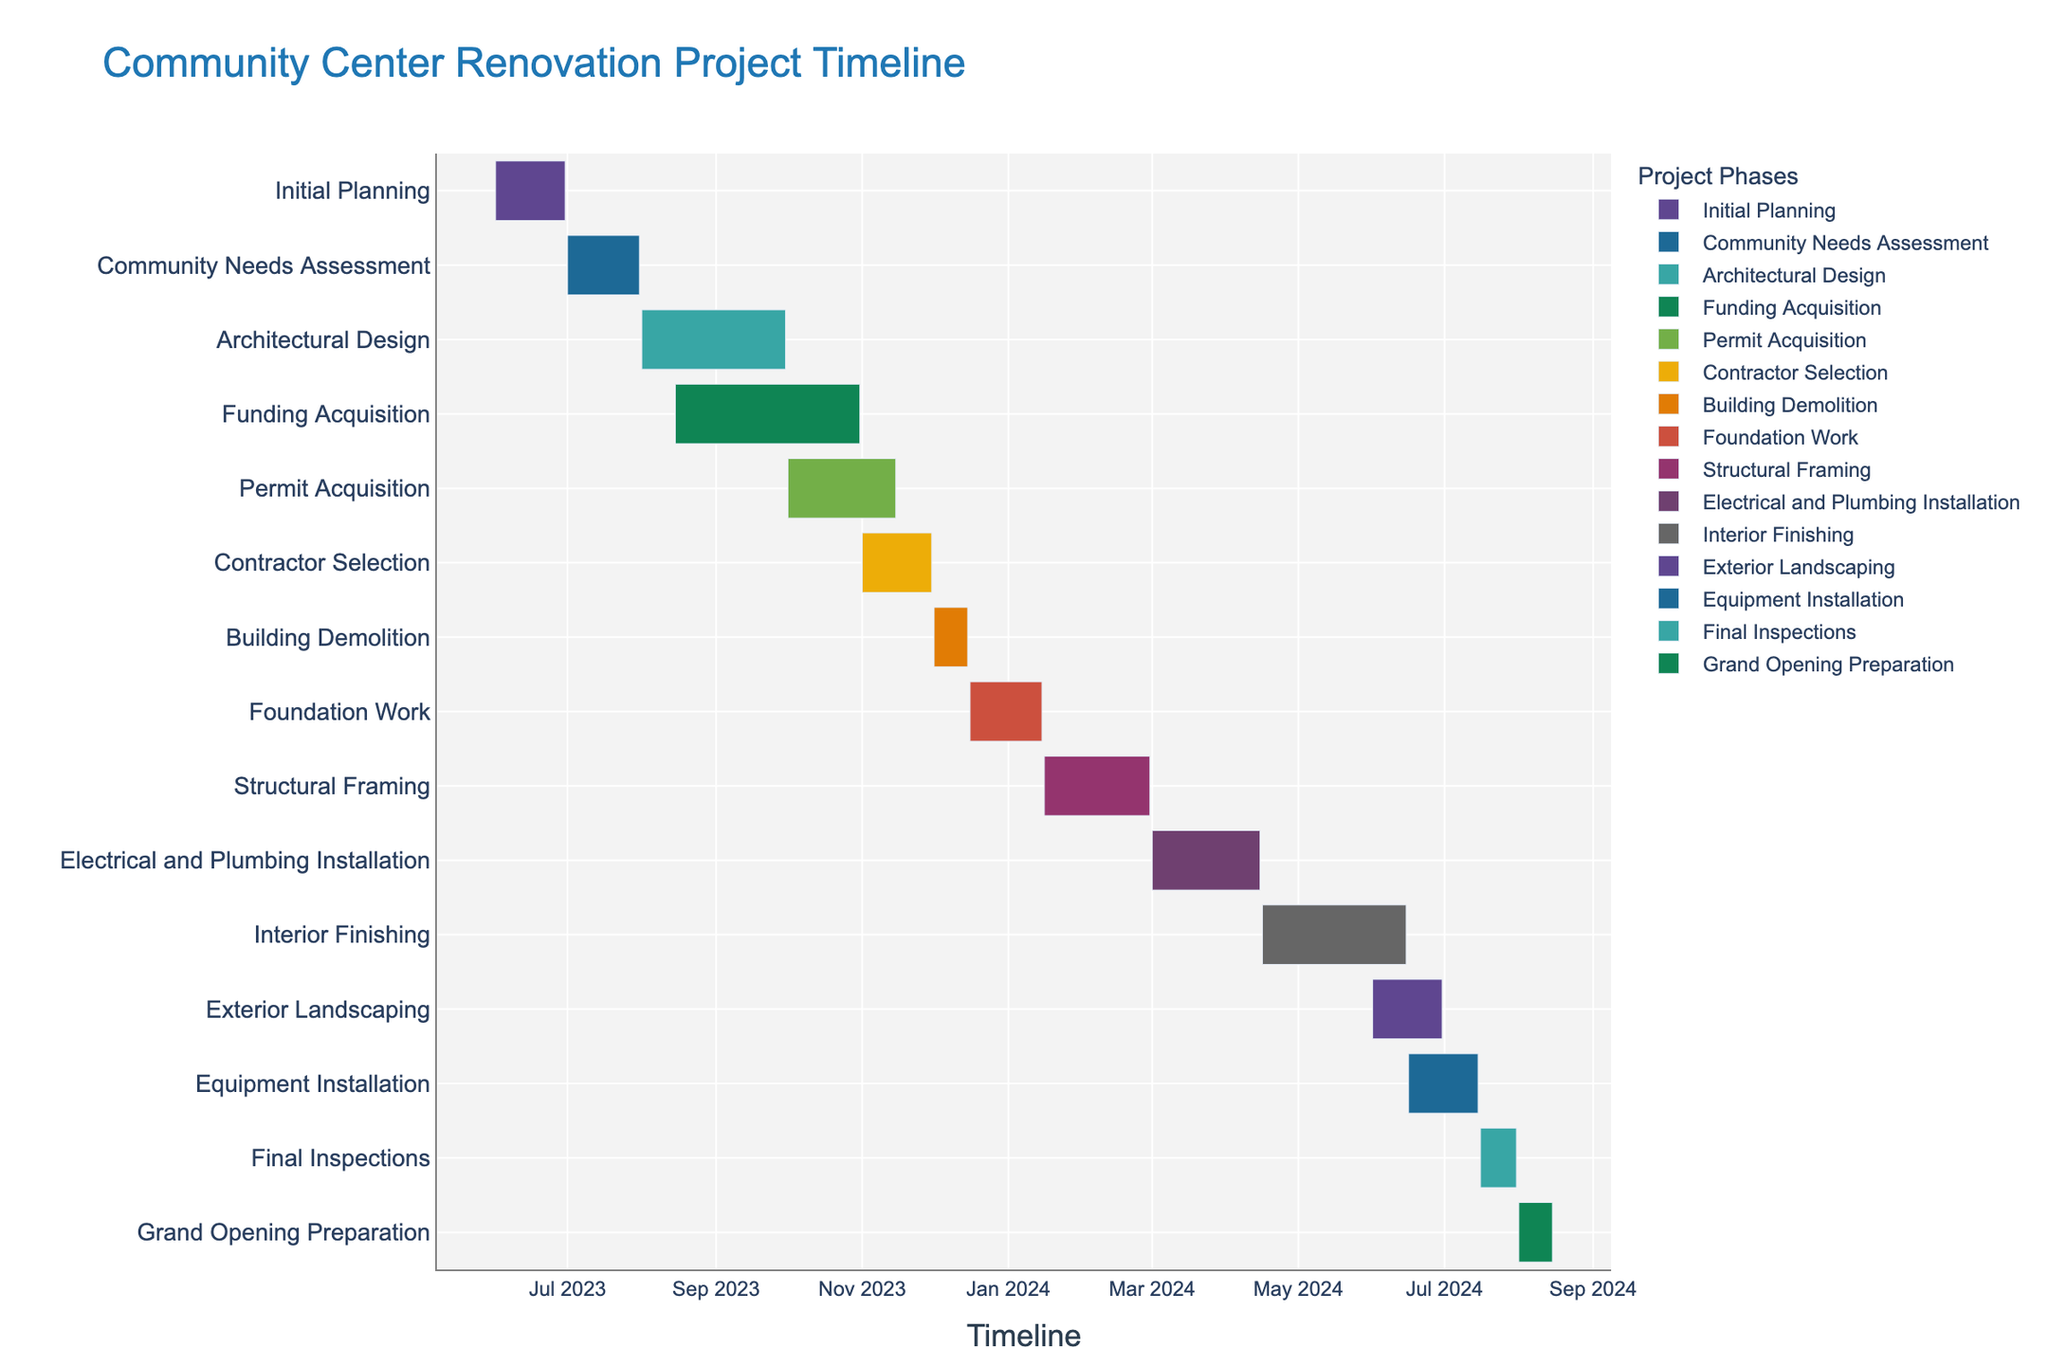what is the title of the figure? The title of the figure is prominently displayed at the top.
Answer: Community Center Renovation Project Timeline What are the start and end dates for the Architectural Design phase? Locate the "Architectural Design" task on the y-axis and trace it to its start and end dates on the x-axis.
Answer: August 1, 2023 to September 30, 2023 How long is the Funding Acquisition phase? Find the "Funding Acquisition" task and calculate the difference between its start date and end date.
Answer: 77 days Which phase follows directly after the Building Demolition phase? Identify the "Building Demolition" task and check which task starts right after its end date.
Answer: Foundation Work Are there any phases overlapping with Electrical and Plumbing Installation? Look for the "Electrical and Plumbing Installation" phase and observe if any other phases have start dates before its end date.
Answer: Interior Finishing When do the Contractor Selection and Permit Acquisition phases overlap? Check the start and end dates of "Contractor Selection" and "Permit Acquisition" to see if there are simultaneous dates.
Answer: November 1, 2023 to November 15, 2023 What is the duration of the Construction phases collectively? Identify the construction-related tasks (Building Demolition, Foundation Work, Structural Framing, Electrical and Plumbing Installation, Interior Finishing, and Equipment Installation), add up their durations.
Answer: 226 days Which tasks occur entirely in January 2024? Find tasks that have both their start and end dates within January 2024.
Answer: Foundation Work, Structural Framing Which project phases are expected to end in the month of June 2024? Look for tasks with end dates falling in June 2024.
Answer: Interior Finishing, Exterior Landscaping What is the longest phase in the project schedule? Compare the durations of all phases to identify the one with the longest duration.
Answer: Architectural Design 